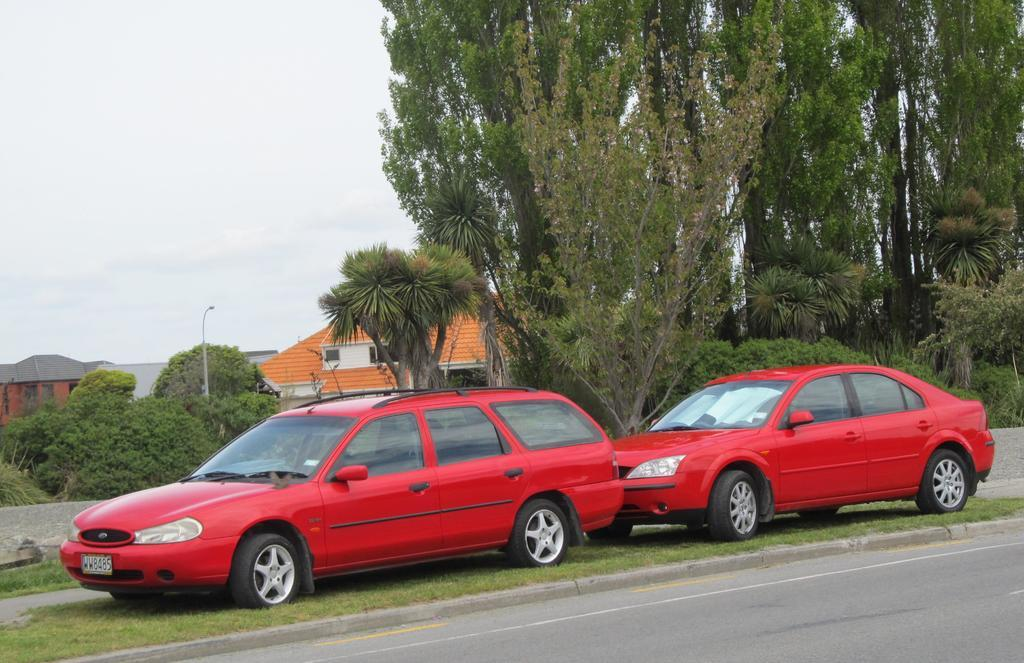What are the main subjects in the center of the image? There are two red vehicles in the center of the image. What can be seen in the background of the image? The sky, clouds, trees, buildings, a pole, grass, and a road are visible in the background of the image. What type of pan is being used by the representative in the image? There is no pan or representative present in the image. Can the can in the image be opened with a can opener? There is no can present in the image. 